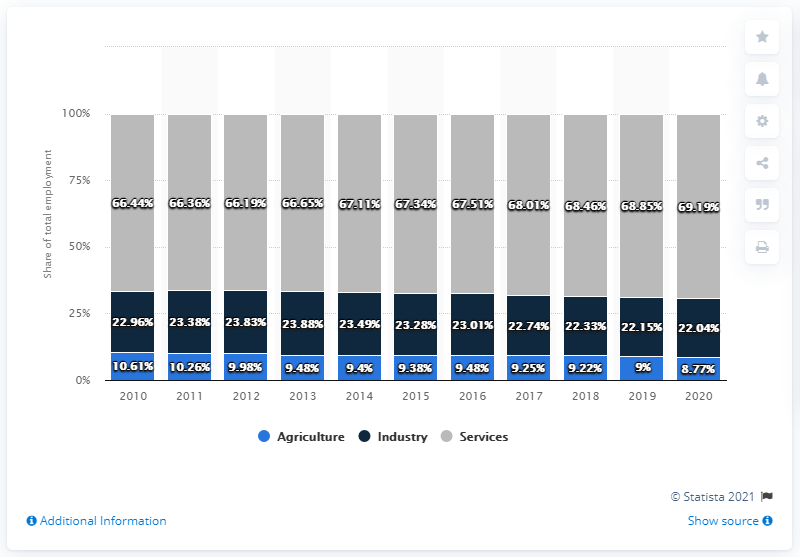Point out several critical features in this image. The highest value in agriculture is 55.58, while the lowest value in services is 55.58. Agriculture is depicted in the chart as being assigned the color blue. 